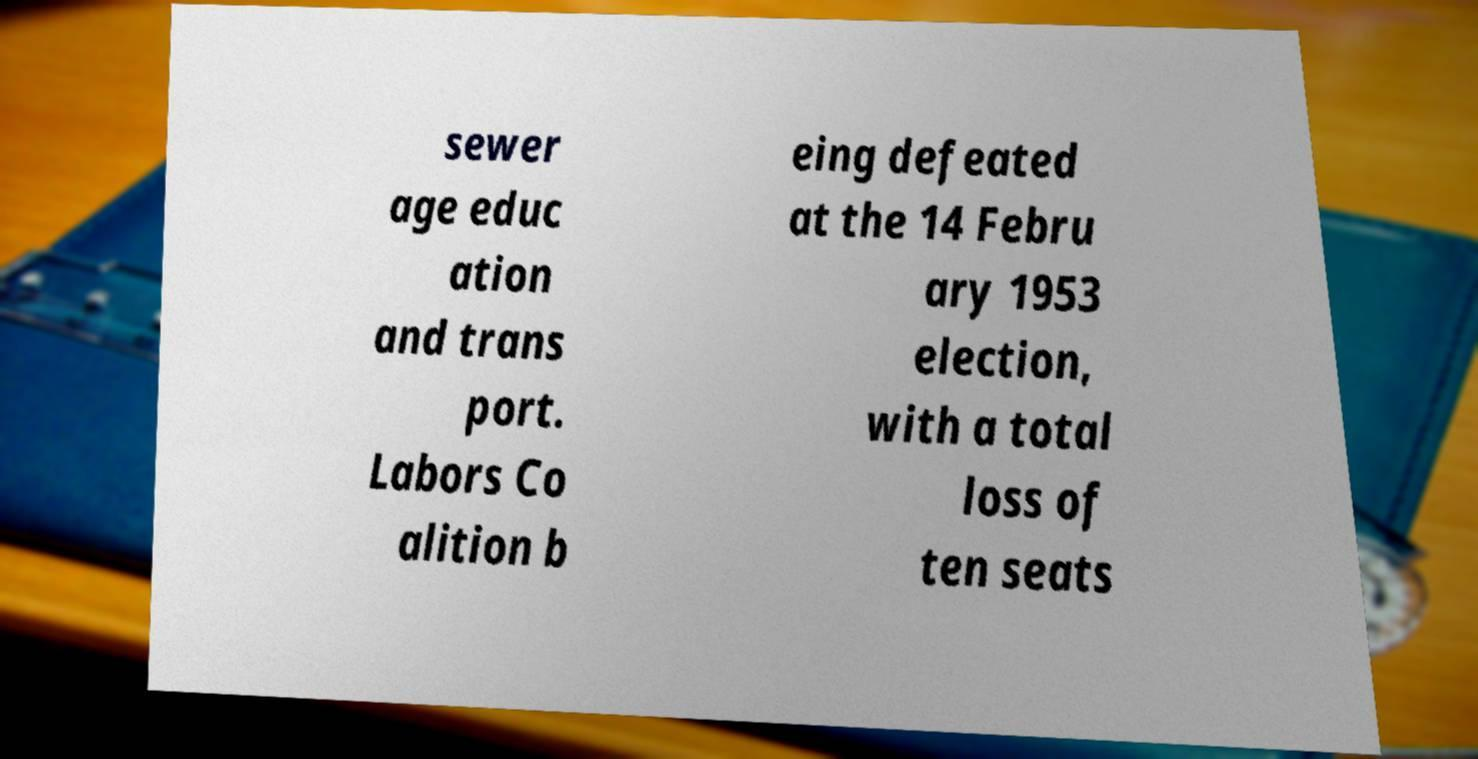Can you read and provide the text displayed in the image?This photo seems to have some interesting text. Can you extract and type it out for me? sewer age educ ation and trans port. Labors Co alition b eing defeated at the 14 Febru ary 1953 election, with a total loss of ten seats 